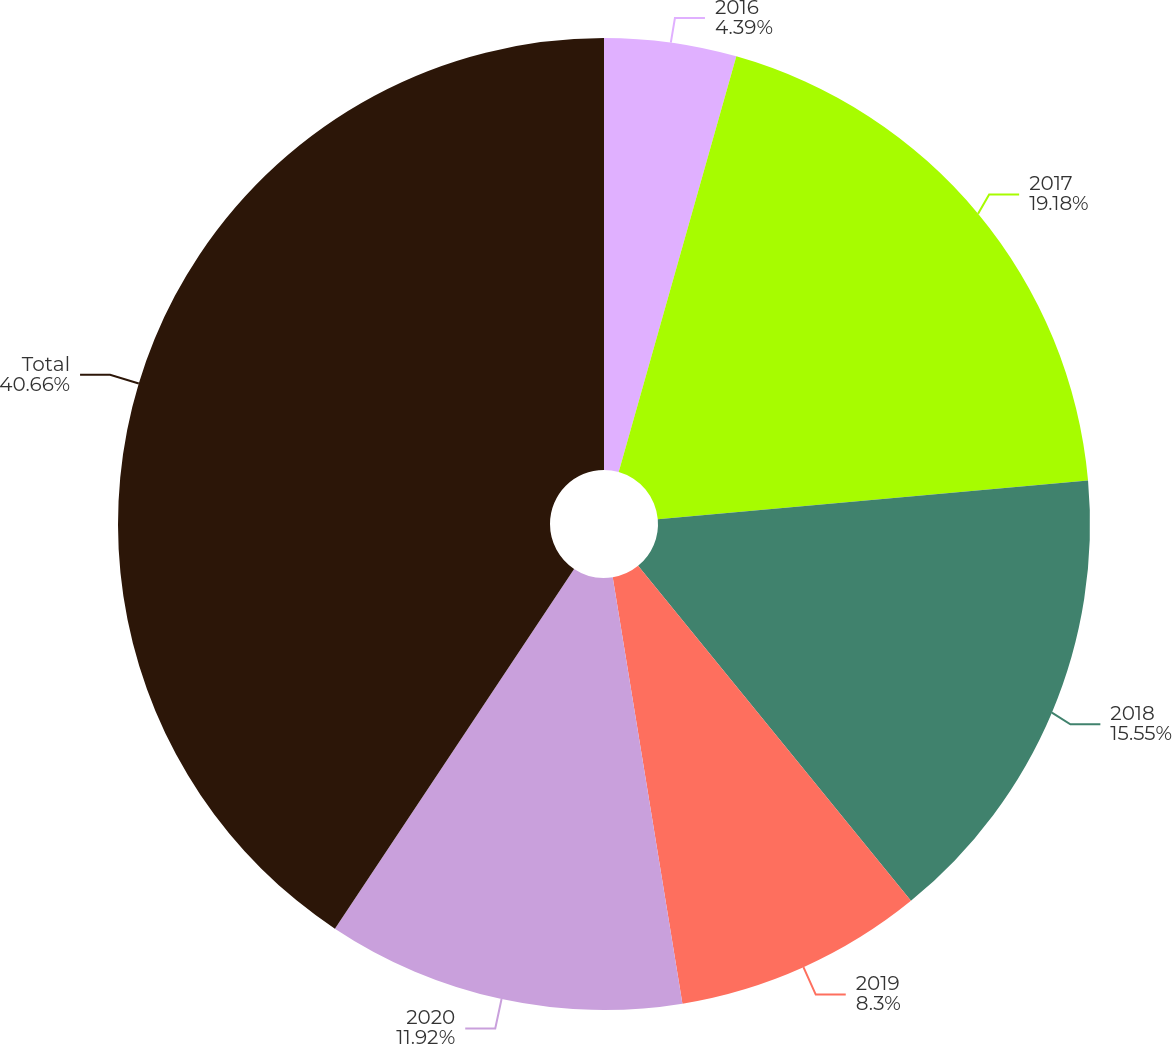Convert chart to OTSL. <chart><loc_0><loc_0><loc_500><loc_500><pie_chart><fcel>2016<fcel>2017<fcel>2018<fcel>2019<fcel>2020<fcel>Total<nl><fcel>4.39%<fcel>19.18%<fcel>15.55%<fcel>8.3%<fcel>11.92%<fcel>40.66%<nl></chart> 